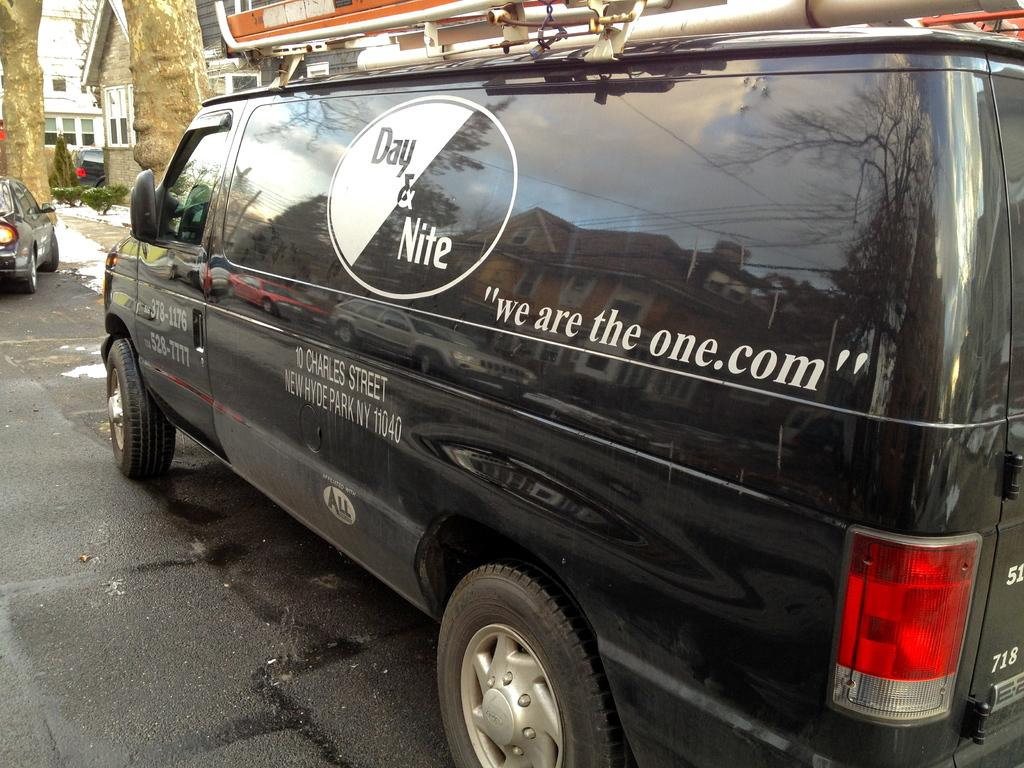What can be seen on the road in the image? There are vehicles on the road in the image. What is visible in the background of the image? There are seeds and trees in the background of the image. What type of ray is cooking in the image? There is no ray or cooking activity present in the image. 